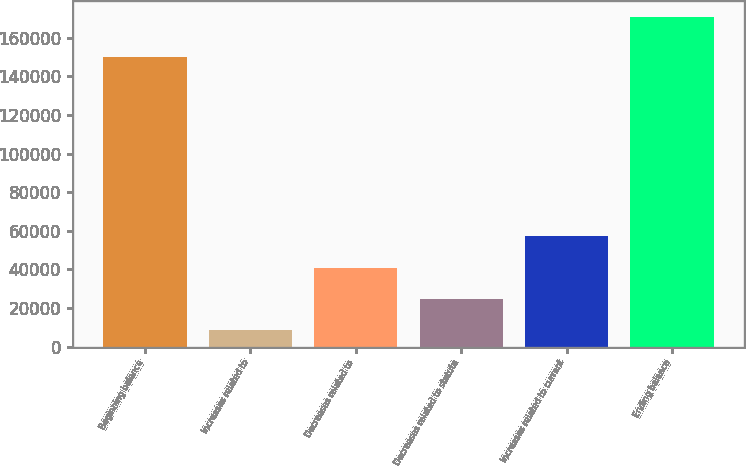<chart> <loc_0><loc_0><loc_500><loc_500><bar_chart><fcel>Beginning balance<fcel>Increases related to<fcel>Decreases related to<fcel>Decreases related to statute<fcel>Increases related to current<fcel>Ending balance<nl><fcel>149878<fcel>8381<fcel>40835.6<fcel>24608.3<fcel>57062.9<fcel>170654<nl></chart> 